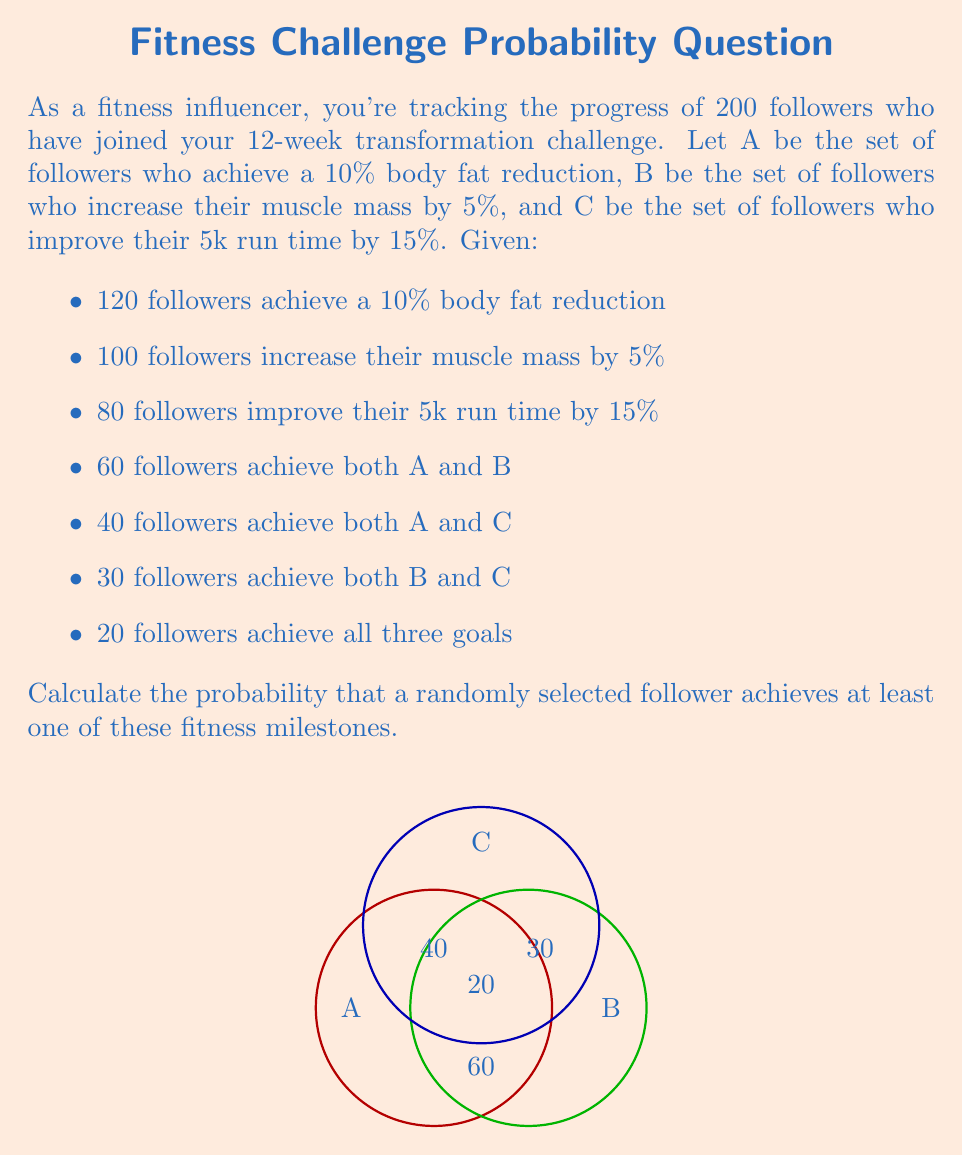What is the answer to this math problem? Let's solve this step-by-step using set theory:

1) First, we need to find the number of followers who achieved at least one milestone. We can use the inclusion-exclusion principle:

   $$|A \cup B \cup C| = |A| + |B| + |C| - |A \cap B| - |A \cap C| - |B \cap C| + |A \cap B \cap C|$$

2) We're given:
   $|A| = 120$, $|B| = 100$, $|C| = 80$
   $|A \cap B| = 60$, $|A \cap C| = 40$, $|B \cap C| = 30$
   $|A \cap B \cap C| = 20$

3) Substituting these values:

   $$|A \cup B \cup C| = 120 + 100 + 80 - 60 - 40 - 30 + 20 = 190$$

4) So, 190 followers achieved at least one milestone.

5) The probability is the number of favorable outcomes divided by the total number of possible outcomes:

   $$P(\text{at least one milestone}) = \frac{\text{followers who achieved at least one milestone}}{\text{total followers}}$$

   $$P(\text{at least one milestone}) = \frac{190}{200} = 0.95$$
Answer: $0.95$ or $95\%$ 